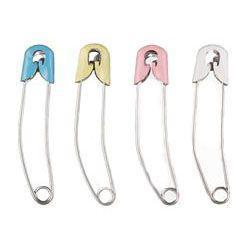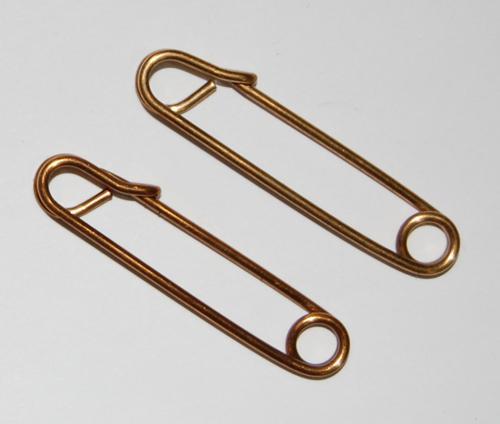The first image is the image on the left, the second image is the image on the right. Assess this claim about the two images: "At least one paperclip is a color other than silver or white.". Correct or not? Answer yes or no. Yes. 